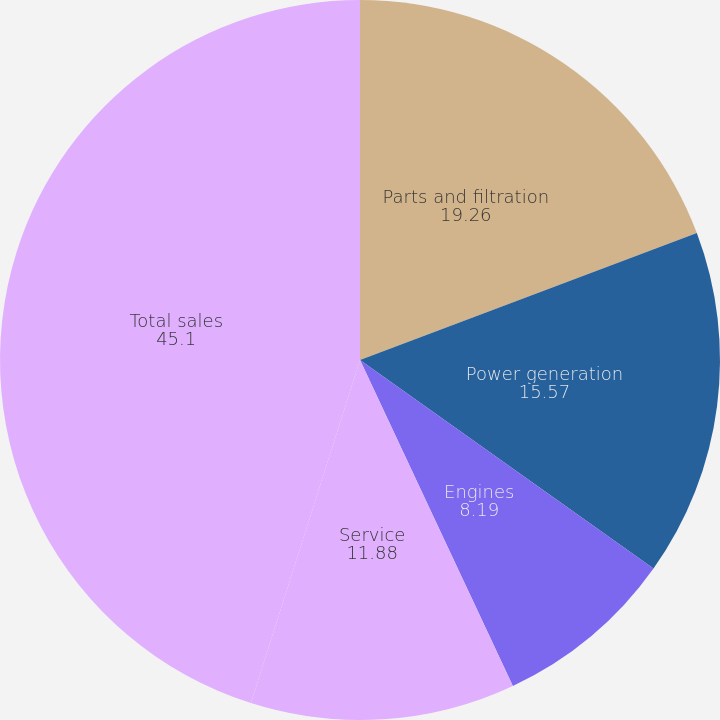Convert chart. <chart><loc_0><loc_0><loc_500><loc_500><pie_chart><fcel>Parts and filtration<fcel>Power generation<fcel>Engines<fcel>Service<fcel>Total sales<nl><fcel>19.26%<fcel>15.57%<fcel>8.19%<fcel>11.88%<fcel>45.1%<nl></chart> 